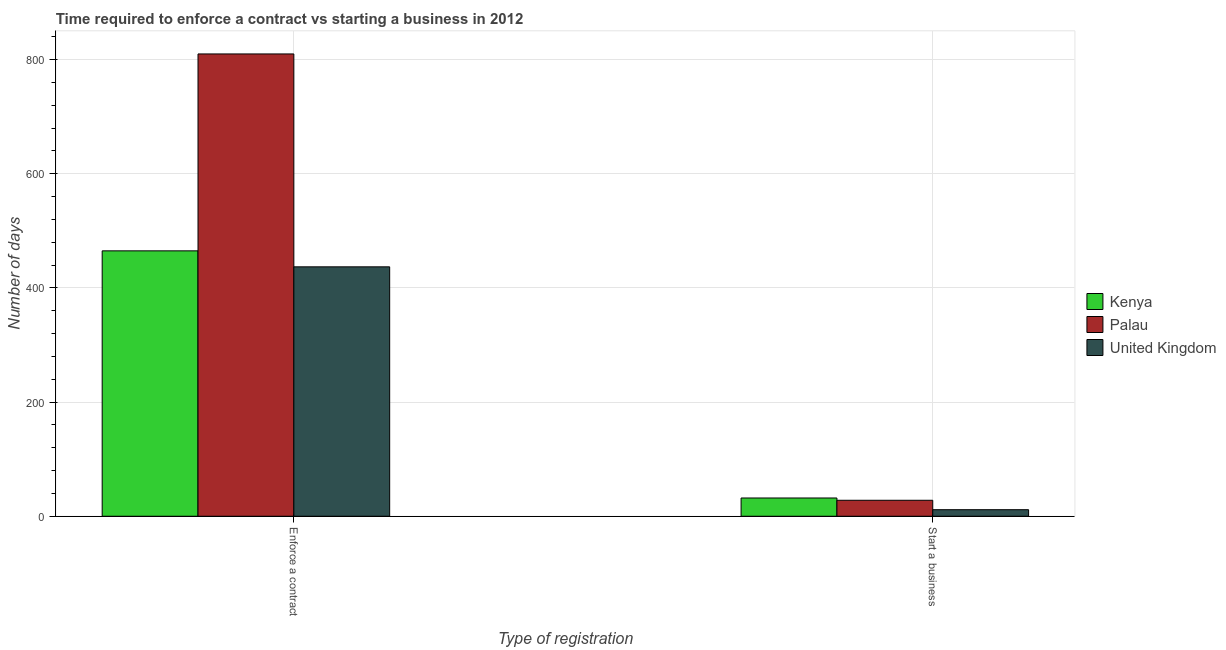Are the number of bars per tick equal to the number of legend labels?
Keep it short and to the point. Yes. What is the label of the 1st group of bars from the left?
Your response must be concise. Enforce a contract. What is the number of days to enforece a contract in Palau?
Provide a short and direct response. 810. Across all countries, what is the minimum number of days to start a business?
Ensure brevity in your answer.  11.5. In which country was the number of days to enforece a contract maximum?
Keep it short and to the point. Palau. In which country was the number of days to enforece a contract minimum?
Provide a succinct answer. United Kingdom. What is the total number of days to enforece a contract in the graph?
Provide a short and direct response. 1712. What is the difference between the number of days to enforece a contract in Kenya and that in Palau?
Give a very brief answer. -345. What is the difference between the number of days to start a business in Kenya and the number of days to enforece a contract in Palau?
Provide a short and direct response. -778. What is the average number of days to start a business per country?
Provide a succinct answer. 23.83. What is the difference between the number of days to start a business and number of days to enforece a contract in Palau?
Make the answer very short. -782. What is the ratio of the number of days to start a business in United Kingdom to that in Kenya?
Provide a succinct answer. 0.36. Is the number of days to start a business in Palau less than that in United Kingdom?
Your response must be concise. No. In how many countries, is the number of days to start a business greater than the average number of days to start a business taken over all countries?
Give a very brief answer. 2. What does the 3rd bar from the left in Enforce a contract represents?
Make the answer very short. United Kingdom. Are all the bars in the graph horizontal?
Make the answer very short. No. How many legend labels are there?
Give a very brief answer. 3. What is the title of the graph?
Ensure brevity in your answer.  Time required to enforce a contract vs starting a business in 2012. Does "Tuvalu" appear as one of the legend labels in the graph?
Your answer should be compact. No. What is the label or title of the X-axis?
Offer a terse response. Type of registration. What is the label or title of the Y-axis?
Provide a short and direct response. Number of days. What is the Number of days in Kenya in Enforce a contract?
Keep it short and to the point. 465. What is the Number of days of Palau in Enforce a contract?
Your response must be concise. 810. What is the Number of days of United Kingdom in Enforce a contract?
Your answer should be compact. 437. What is the Number of days of Kenya in Start a business?
Make the answer very short. 32. What is the Number of days of Palau in Start a business?
Provide a short and direct response. 28. Across all Type of registration, what is the maximum Number of days in Kenya?
Your answer should be compact. 465. Across all Type of registration, what is the maximum Number of days in Palau?
Your response must be concise. 810. Across all Type of registration, what is the maximum Number of days in United Kingdom?
Your answer should be very brief. 437. Across all Type of registration, what is the minimum Number of days in Kenya?
Give a very brief answer. 32. Across all Type of registration, what is the minimum Number of days in United Kingdom?
Offer a terse response. 11.5. What is the total Number of days of Kenya in the graph?
Your answer should be very brief. 497. What is the total Number of days of Palau in the graph?
Provide a succinct answer. 838. What is the total Number of days in United Kingdom in the graph?
Your answer should be compact. 448.5. What is the difference between the Number of days in Kenya in Enforce a contract and that in Start a business?
Keep it short and to the point. 433. What is the difference between the Number of days of Palau in Enforce a contract and that in Start a business?
Your response must be concise. 782. What is the difference between the Number of days of United Kingdom in Enforce a contract and that in Start a business?
Make the answer very short. 425.5. What is the difference between the Number of days in Kenya in Enforce a contract and the Number of days in Palau in Start a business?
Provide a succinct answer. 437. What is the difference between the Number of days in Kenya in Enforce a contract and the Number of days in United Kingdom in Start a business?
Provide a succinct answer. 453.5. What is the difference between the Number of days of Palau in Enforce a contract and the Number of days of United Kingdom in Start a business?
Your response must be concise. 798.5. What is the average Number of days in Kenya per Type of registration?
Your response must be concise. 248.5. What is the average Number of days in Palau per Type of registration?
Make the answer very short. 419. What is the average Number of days of United Kingdom per Type of registration?
Keep it short and to the point. 224.25. What is the difference between the Number of days in Kenya and Number of days in Palau in Enforce a contract?
Your answer should be very brief. -345. What is the difference between the Number of days in Palau and Number of days in United Kingdom in Enforce a contract?
Provide a succinct answer. 373. What is the ratio of the Number of days in Kenya in Enforce a contract to that in Start a business?
Ensure brevity in your answer.  14.53. What is the ratio of the Number of days of Palau in Enforce a contract to that in Start a business?
Your response must be concise. 28.93. What is the ratio of the Number of days in United Kingdom in Enforce a contract to that in Start a business?
Your answer should be very brief. 38. What is the difference between the highest and the second highest Number of days in Kenya?
Provide a succinct answer. 433. What is the difference between the highest and the second highest Number of days in Palau?
Your answer should be compact. 782. What is the difference between the highest and the second highest Number of days of United Kingdom?
Make the answer very short. 425.5. What is the difference between the highest and the lowest Number of days in Kenya?
Offer a terse response. 433. What is the difference between the highest and the lowest Number of days in Palau?
Offer a terse response. 782. What is the difference between the highest and the lowest Number of days in United Kingdom?
Offer a very short reply. 425.5. 